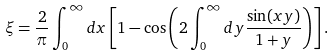Convert formula to latex. <formula><loc_0><loc_0><loc_500><loc_500>\xi = \frac { 2 } { \pi } \int _ { 0 } ^ { \infty } d x \left [ 1 - \cos \left ( 2 \int _ { 0 } ^ { \infty } d y \frac { \sin ( x y ) } { 1 + y } \right ) \right ] .</formula> 